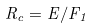<formula> <loc_0><loc_0><loc_500><loc_500>R _ { c } = E / F _ { 1 }</formula> 